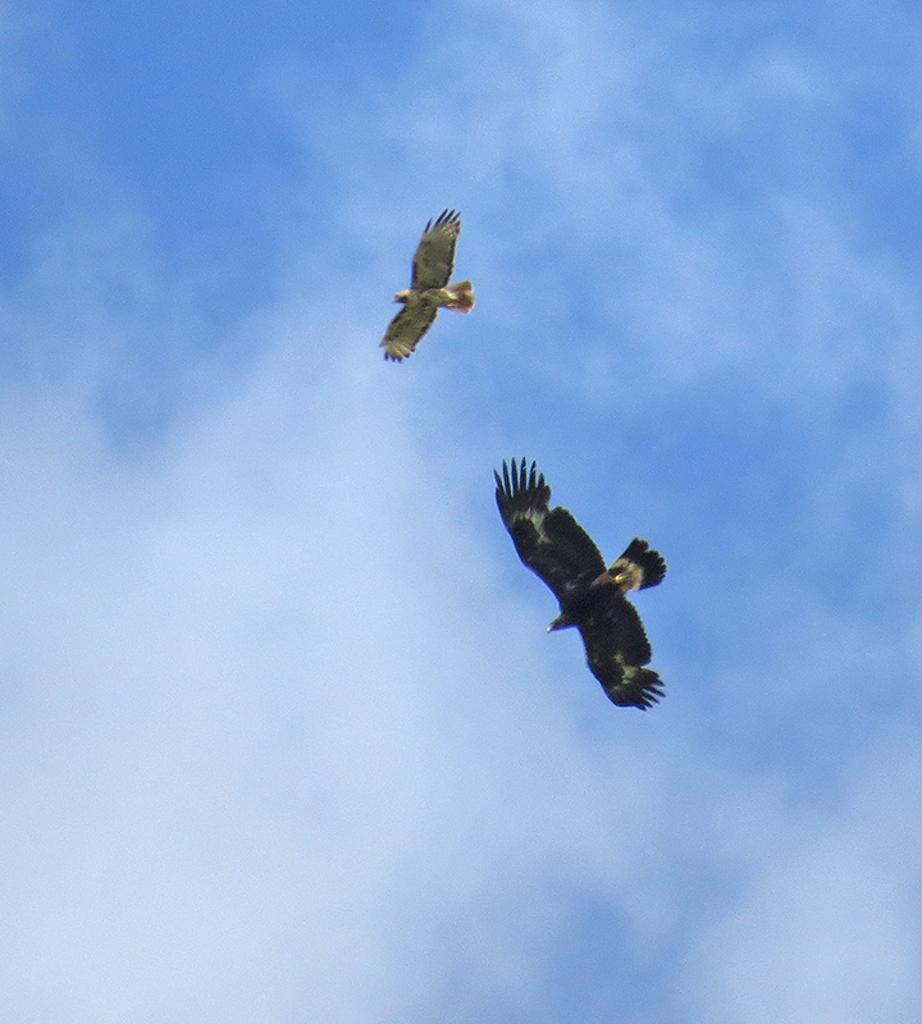Could you give a brief overview of what you see in this image? In this image I can see two birds are flying in the air. In the background, I can see the sky and clouds. 